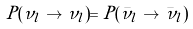Convert formula to latex. <formula><loc_0><loc_0><loc_500><loc_500>P ( \nu _ { l } \to \nu _ { l } ) = P ( \bar { \nu } _ { l } \to \bar { \nu } _ { l } )</formula> 